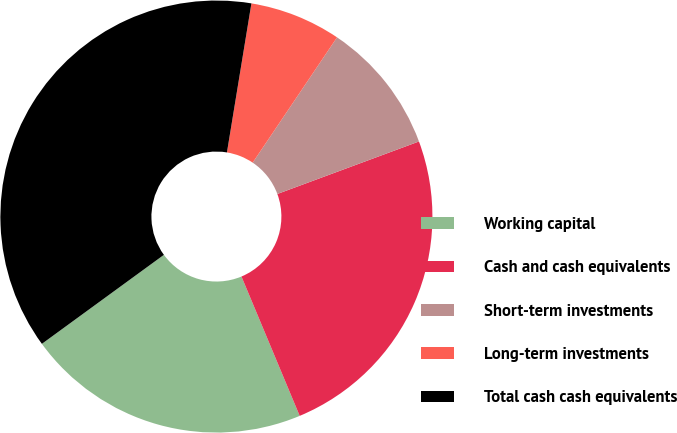Convert chart to OTSL. <chart><loc_0><loc_0><loc_500><loc_500><pie_chart><fcel>Working capital<fcel>Cash and cash equivalents<fcel>Short-term investments<fcel>Long-term investments<fcel>Total cash cash equivalents<nl><fcel>21.27%<fcel>24.35%<fcel>9.92%<fcel>6.84%<fcel>37.62%<nl></chart> 